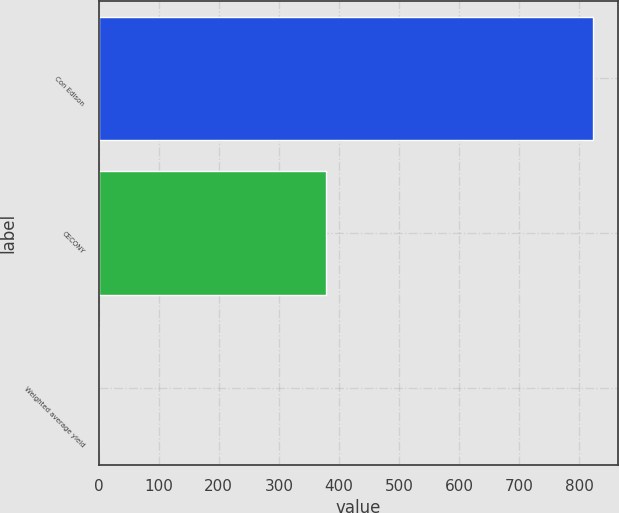Convert chart. <chart><loc_0><loc_0><loc_500><loc_500><bar_chart><fcel>Con Edison<fcel>CECONY<fcel>Weighted average yield<nl><fcel>823<fcel>379<fcel>0.4<nl></chart> 